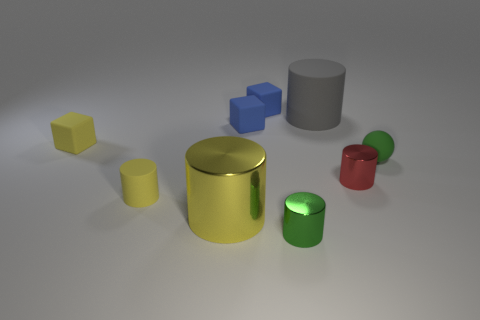Is the material of the tiny yellow cylinder the same as the big cylinder that is on the left side of the small green cylinder? Based on the image, the tiny yellow cylinder appears to be of a similar material as the larger cylinder to its left, which may suggest both are made of a reflective material, possibly metal or a reflective plastic. However, without more context or the ability to physically examine the objects, it's challenging to confirm if the materials are indeed the same. 